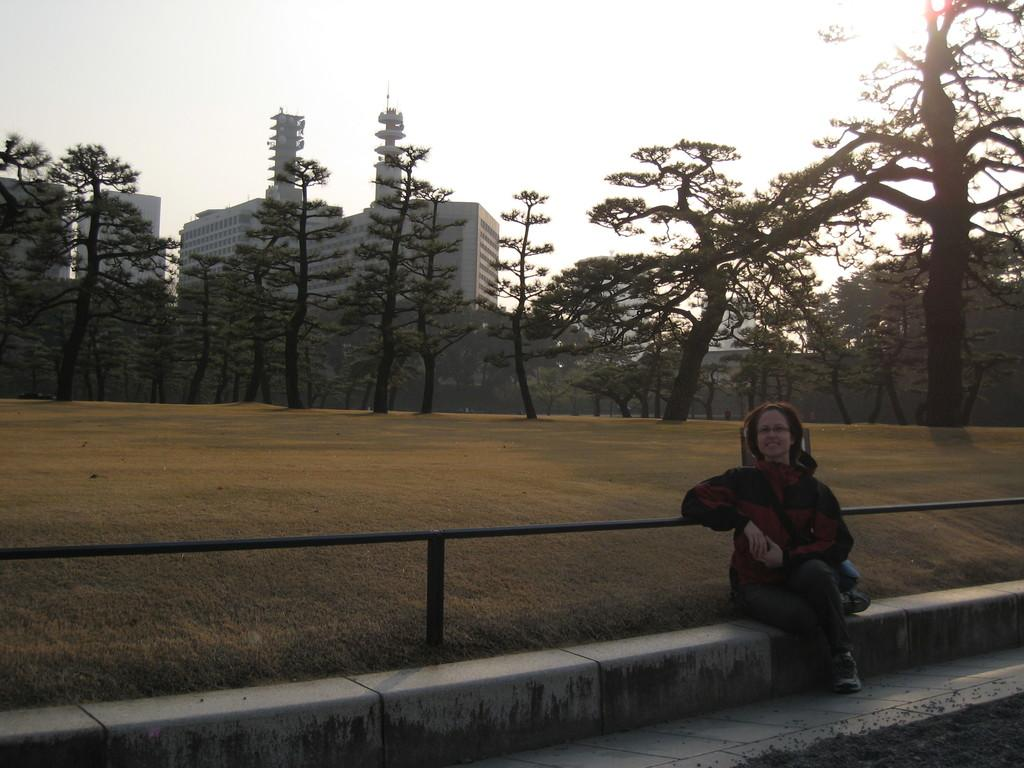Who is the main subject in the image? There is a woman sitting in the front of the image. What can be seen in the background of the image? There are trees and buildings in the background of the image. What is visible at the top of the image? The sky is visible at the top of the image. What type of account does the woman have in the image? There is no mention of an account in the image, as it features a woman sitting in the front with trees, buildings, and the sky in the background. 